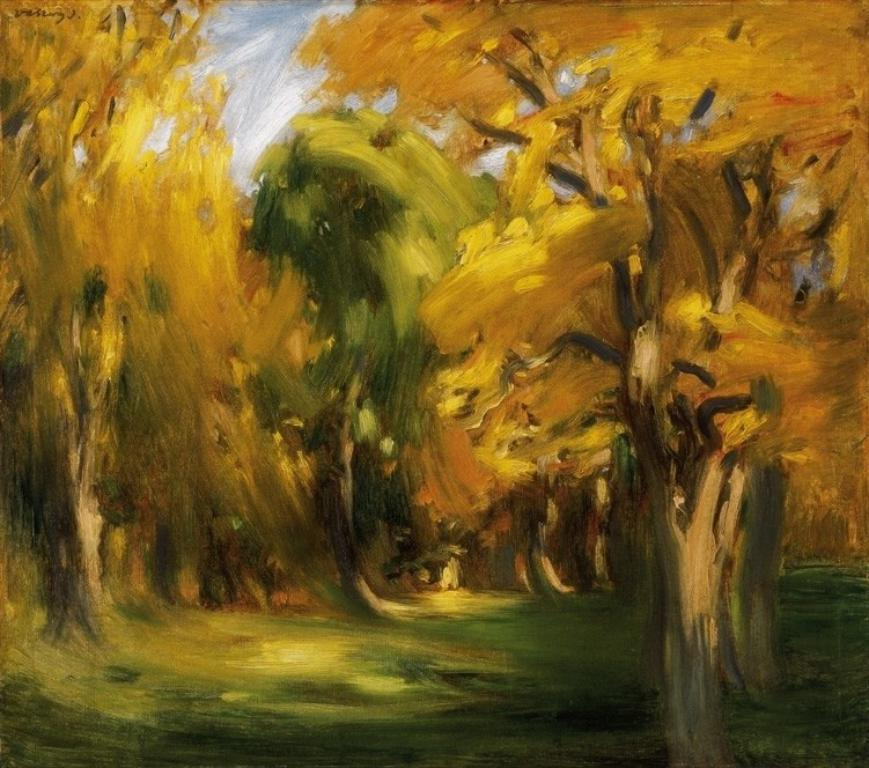What is the main subject of the image? The image contains a painting. What is depicted in the painting? The painting depicts trees and the sky. Can you see a rabbit hopping in the painting? There is no rabbit present in the painting; it depicts trees and the sky. What is the painting's desire to roll down the hill? The painting is not a living being and therefore cannot have desires or actions like rolling down a hill. 